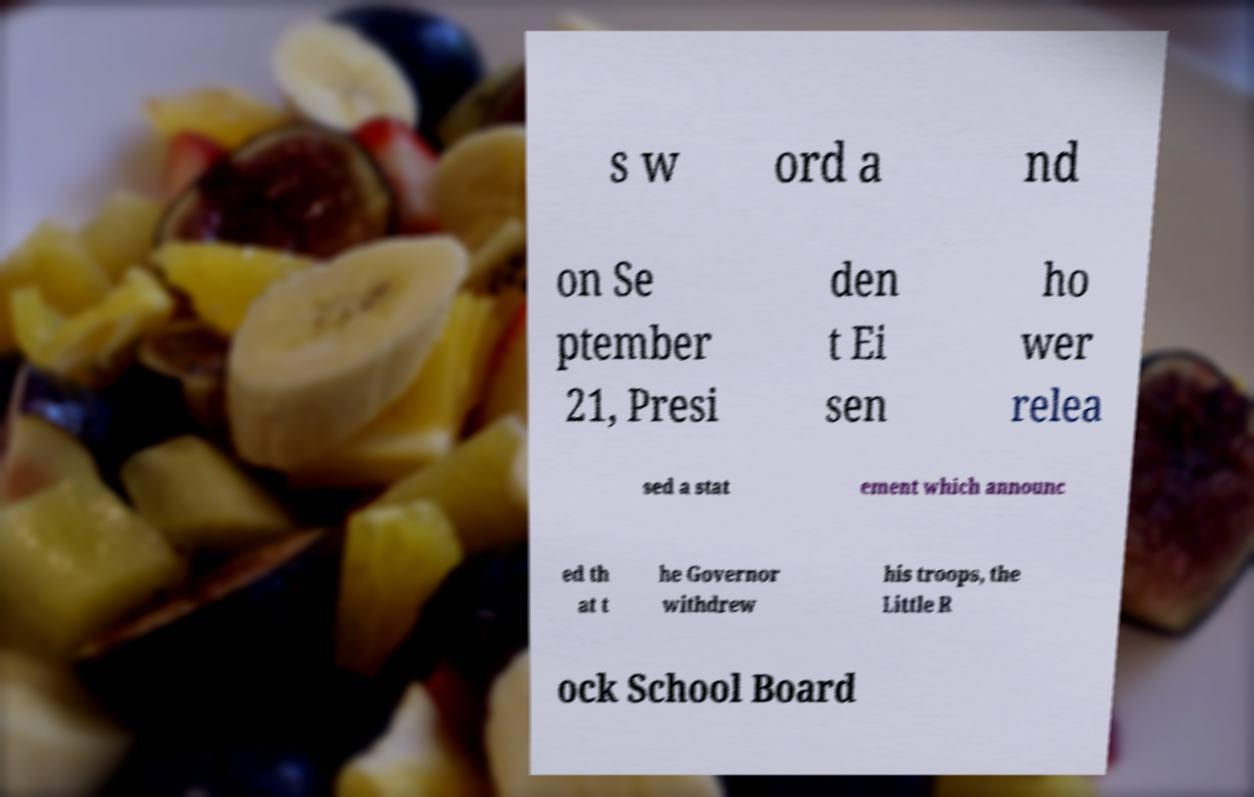Could you assist in decoding the text presented in this image and type it out clearly? s w ord a nd on Se ptember 21, Presi den t Ei sen ho wer relea sed a stat ement which announc ed th at t he Governor withdrew his troops, the Little R ock School Board 